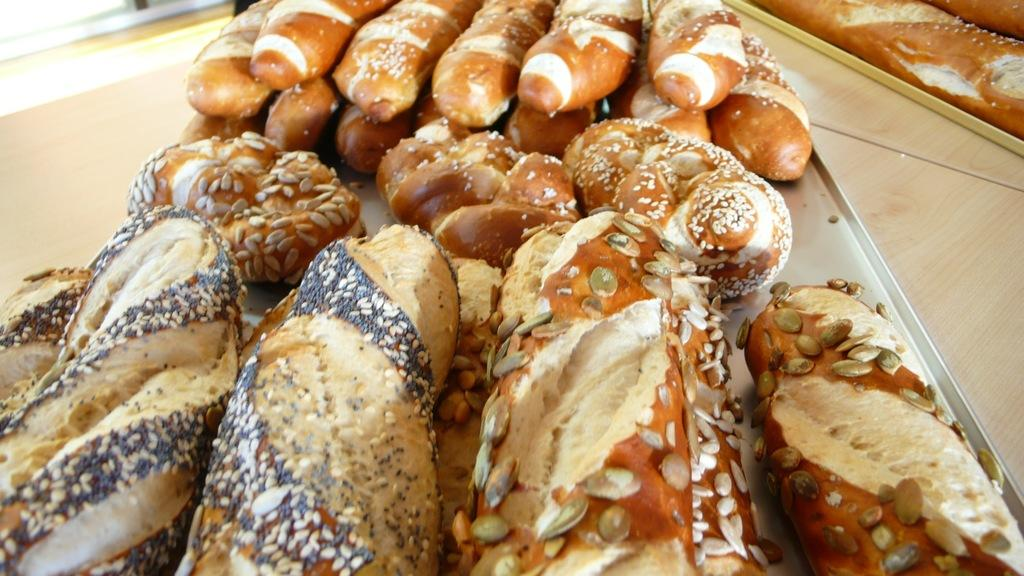What type of objects can be seen in the image? There are food items in the image. Where are the food items located? The food items are in the tray. What colors are the food items in the image? The food items are in brown, cream, and black colors. What is the surface that the tray is placed on? The tray is on a wooden surface. What type of bait is used to catch fish in the image? There is no bait or fishing activity present in the image; it features food items in a tray on a wooden surface. What room is the food tray located in the image? The image does not provide information about the room or location where the food tray is placed. 